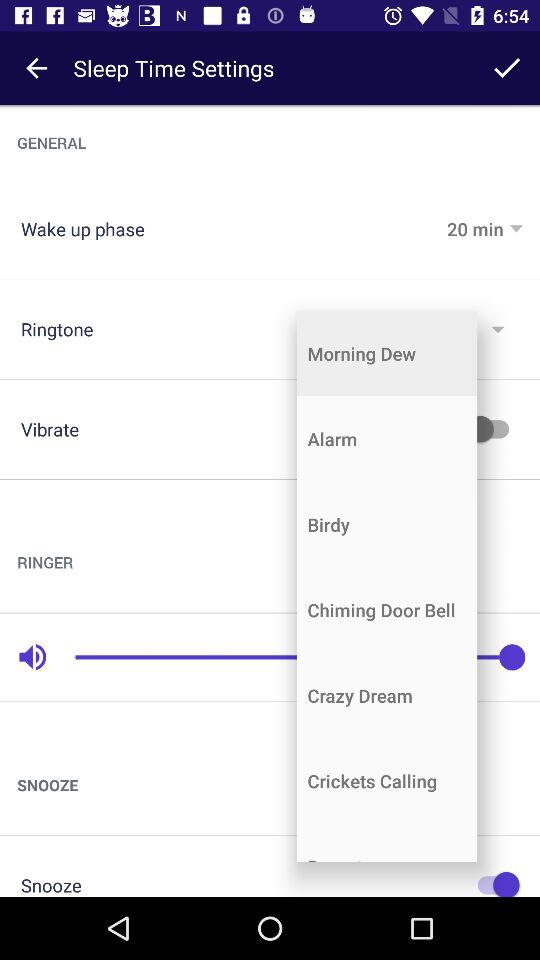What is the selected ringtone? The selected ringtone is "Morning Dew". 